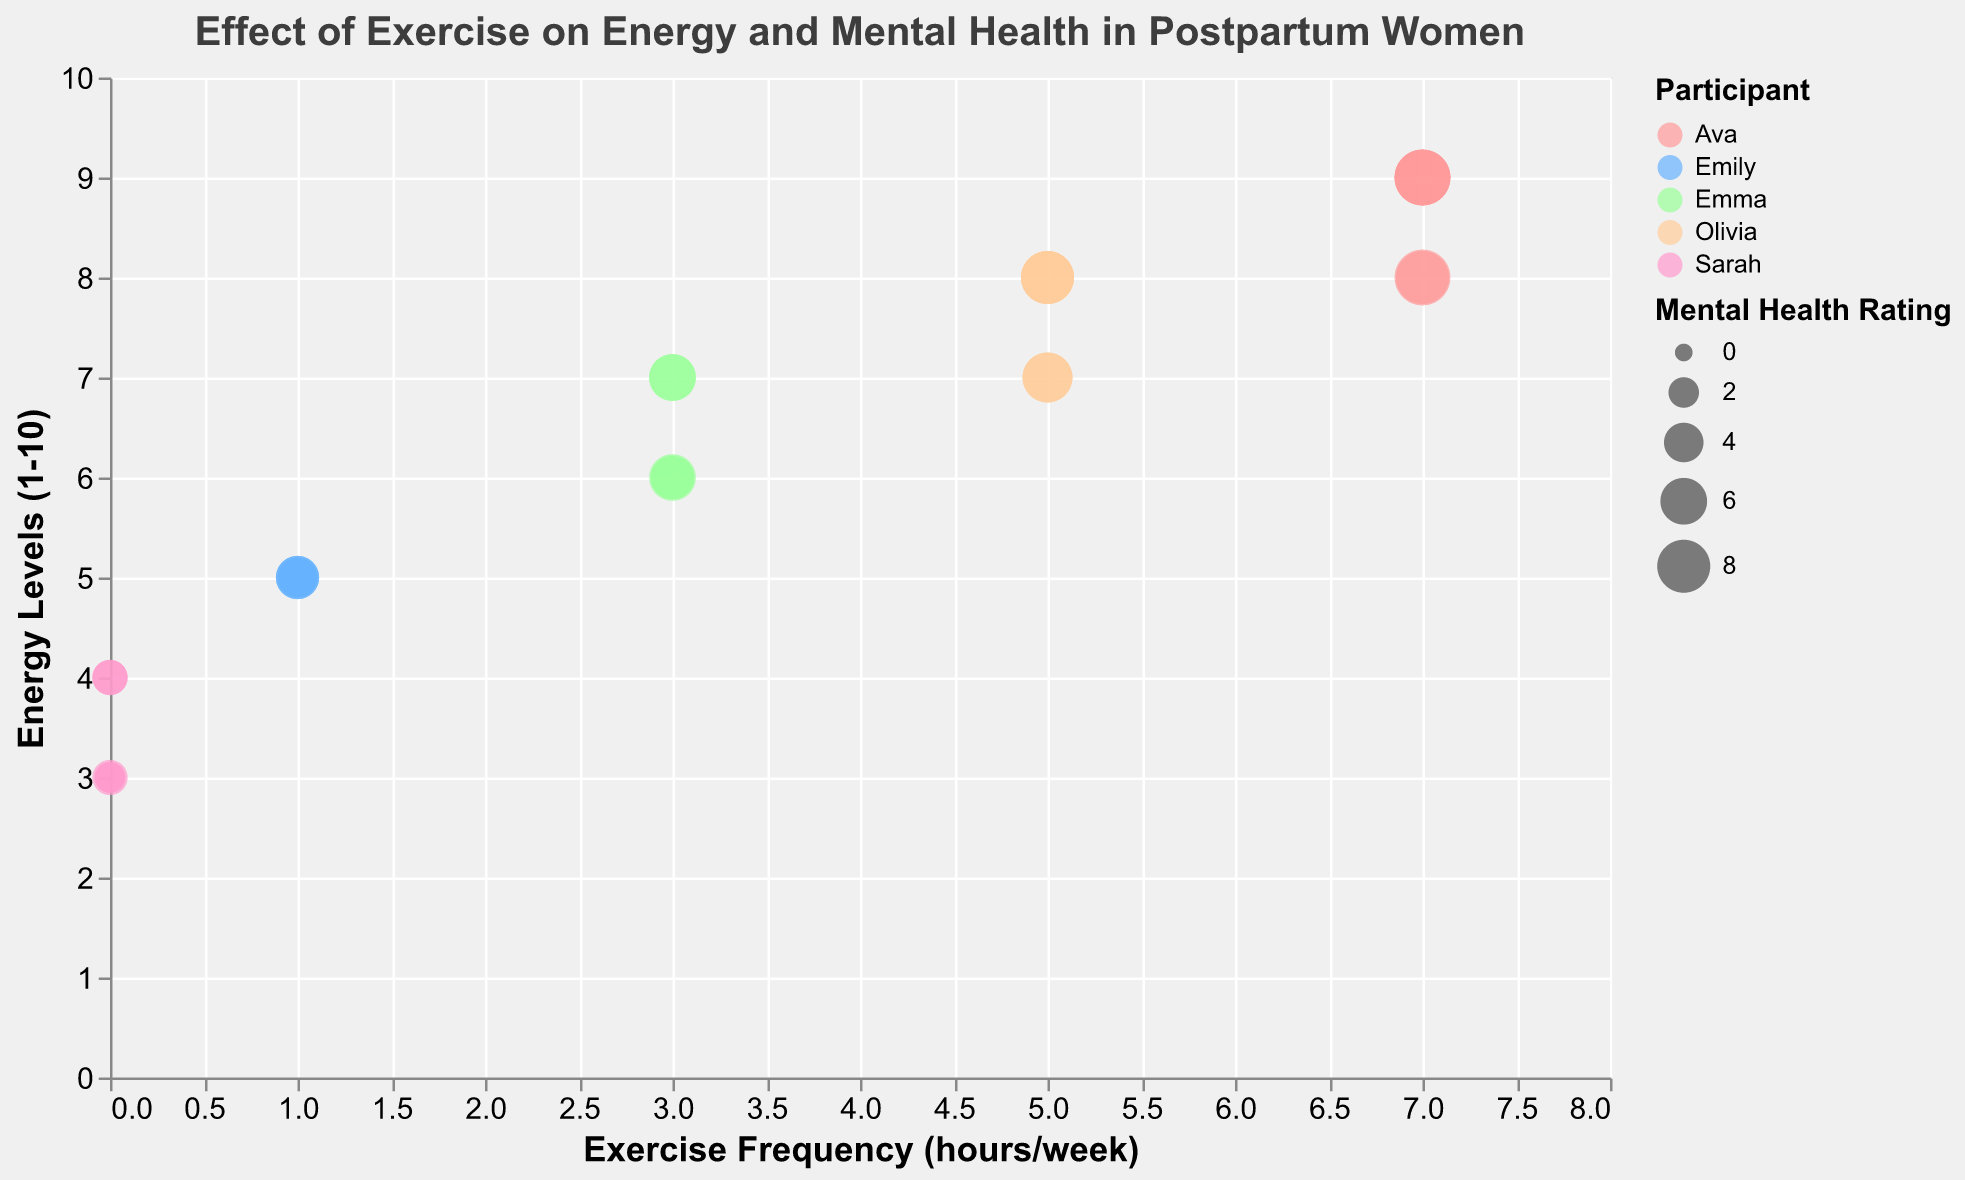What is the title of the bubble chart? The title is directly displayed at the top of the chart.
Answer: Effect of Exercise on Energy and Mental Health in Postpartum Women How does exercise frequency correlate with energy levels? By observing the plot, we can see that as exercise frequency increases, the energy levels tend to increase proportionally. This is indicated by most bubbles moving upwards along the y-axis as they move right along the x-axis.
Answer: Positive correlation Which participant had the highest energy level at 7 hours per week of exercise? The tooltip information shows that Ava (colored bubble) had the highest energy level of 9 with 7 hours per week of exercise in multiple weeks.
Answer: Ava What is the range of mental health ratings represented by the size of the bubbles? The legend for the bubble sizes indicates that the mental health ratings range from 2 to 9.
Answer: 2 to 9 How do Emily's energy levels change from week 1 to week 5 with 1 hour of exercise per week? By finding Emily's data points (color associated with her name) and tracking her energy level each week, we see: Week 1: 5, Week 2: 5, Week 3: 5, Week 4: 5, Week 5: 5. It shows consistent energy levels at 5.
Answer: Consistent at 5 Which week did Sarah have the lowest mental health rating and what was her exercise frequency that week? By looking at the bubble size for Sarah (associated color), Sarah had the lowest mental health rating of 2 during Week 2 with 0 hours of exercise.
Answer: Week 2, 0 hours Compared to other participants, how does Olivia's energy level change with different exercise frequencies? By tracking Olivia's bubbles (color associated with her name) across different exercise frequencies, we observe higher energy levels with increased exercise from 7 to 8. Her energy increases proportionately from 7 to 8 with 5 hours of exercise per week.
Answer: Increases proportionately What is the trend for mental health ratings as exercise frequency increases for Emma? By observing the size of Emma's bubbles (color associated with her name) with increasing exercise, her mental health rating improves slightly, shown by larger bubbles.
Answer: Slight improvement Do any participants have overlapping exercise frequencies and identical energy and mental health levels? By looking for overlapping bubbles, we notice that participants have distinct energy and mental health levels for the same exercise frequencies, indicating no exact overlaps in this dataset.
Answer: No overlapping 